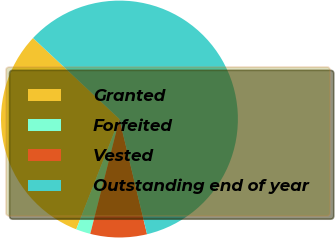Convert chart to OTSL. <chart><loc_0><loc_0><loc_500><loc_500><pie_chart><fcel>Granted<fcel>Forfeited<fcel>Vested<fcel>Outstanding end of year<nl><fcel>31.05%<fcel>1.98%<fcel>7.71%<fcel>59.27%<nl></chart> 